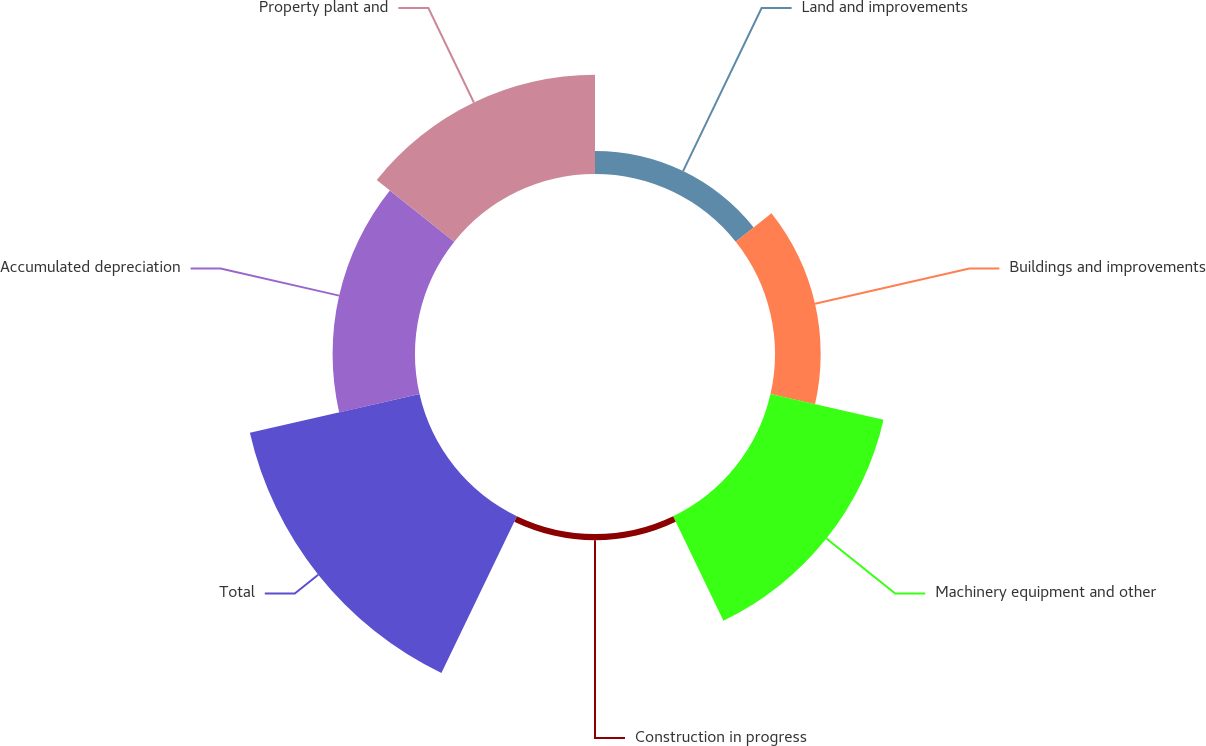Convert chart to OTSL. <chart><loc_0><loc_0><loc_500><loc_500><pie_chart><fcel>Land and improvements<fcel>Buildings and improvements<fcel>Machinery equipment and other<fcel>Construction in progress<fcel>Total<fcel>Accumulated depreciation<fcel>Property plant and<nl><fcel>4.21%<fcel>8.36%<fcel>21.22%<fcel>1.14%<fcel>31.84%<fcel>15.08%<fcel>18.15%<nl></chart> 